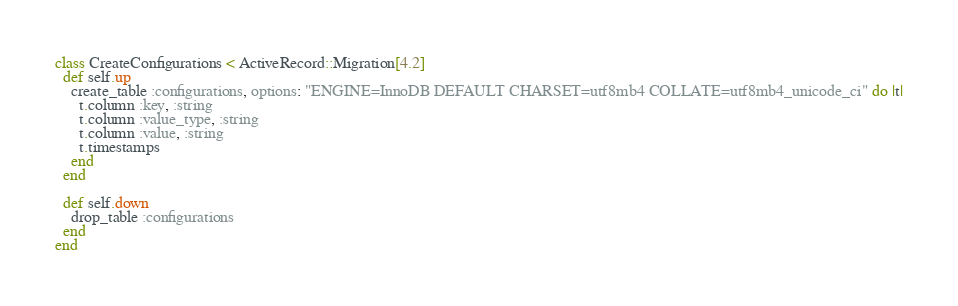<code> <loc_0><loc_0><loc_500><loc_500><_Ruby_>class CreateConfigurations < ActiveRecord::Migration[4.2]
  def self.up
    create_table :configurations, options: "ENGINE=InnoDB DEFAULT CHARSET=utf8mb4 COLLATE=utf8mb4_unicode_ci" do |t|
      t.column :key, :string
      t.column :value_type, :string
      t.column :value, :string
      t.timestamps
    end
  end

  def self.down
    drop_table :configurations
  end
end
</code> 